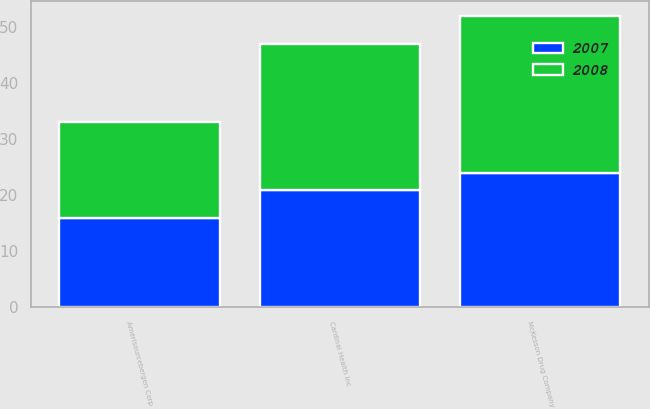<chart> <loc_0><loc_0><loc_500><loc_500><stacked_bar_chart><ecel><fcel>McKesson Drug Company<fcel>Cardinal Health Inc<fcel>Amerisourcebergen Corp<nl><fcel>2007<fcel>24<fcel>21<fcel>16<nl><fcel>2008<fcel>28<fcel>26<fcel>17<nl></chart> 